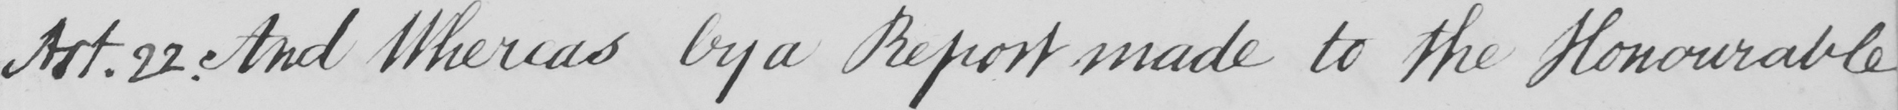Can you read and transcribe this handwriting? Art . 22 . And Whereas by a Report made to the Honourable 